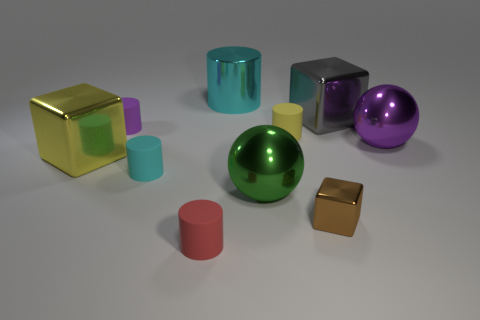There is a small cyan cylinder left of the cyan shiny thing; what is it made of?
Provide a succinct answer. Rubber. There is a gray cube that is behind the brown object; what number of cubes are in front of it?
Provide a short and direct response. 2. Is there a gray thing of the same shape as the green object?
Your answer should be compact. No. Does the purple object to the right of the metallic cylinder have the same size as the sphere left of the tiny yellow matte cylinder?
Keep it short and to the point. Yes. There is a cyan thing that is in front of the metal block to the left of the tiny purple matte object; what is its shape?
Provide a short and direct response. Cylinder. How many cylinders are the same size as the red thing?
Keep it short and to the point. 3. Are any gray balls visible?
Provide a succinct answer. No. Are there any other things of the same color as the big cylinder?
Your answer should be very brief. Yes. There is a purple object that is made of the same material as the tiny cube; what shape is it?
Your answer should be compact. Sphere. The ball that is left of the purple object in front of the small cylinder on the right side of the red matte thing is what color?
Your answer should be very brief. Green. 